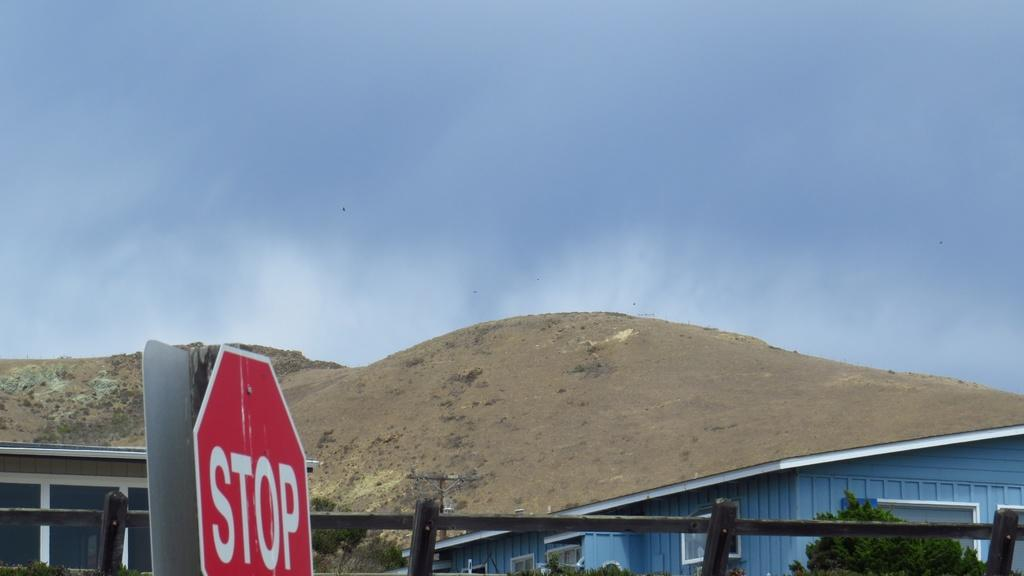<image>
Relay a brief, clear account of the picture shown. A stop sign with some hills and a house in the background. 